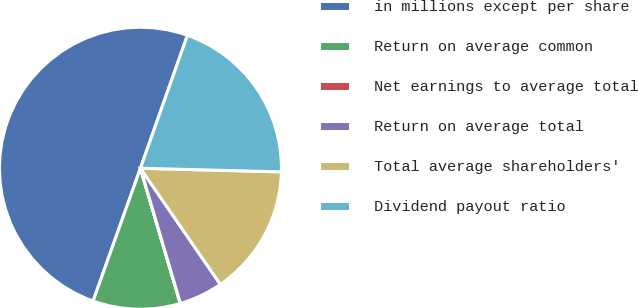Convert chart. <chart><loc_0><loc_0><loc_500><loc_500><pie_chart><fcel>in millions except per share<fcel>Return on average common<fcel>Net earnings to average total<fcel>Return on average total<fcel>Total average shareholders'<fcel>Dividend payout ratio<nl><fcel>49.96%<fcel>10.01%<fcel>0.02%<fcel>5.01%<fcel>15.0%<fcel>20.0%<nl></chart> 